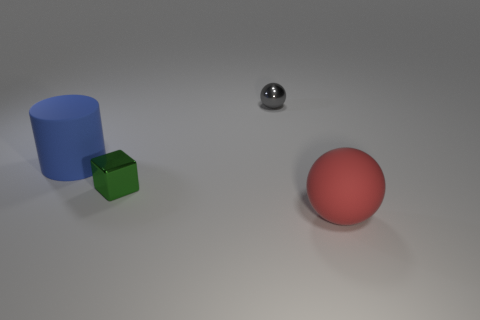Add 2 big brown shiny cylinders. How many objects exist? 6 Subtract all cubes. How many objects are left? 3 Add 4 rubber things. How many rubber things are left? 6 Add 2 big blue cylinders. How many big blue cylinders exist? 3 Subtract 0 brown balls. How many objects are left? 4 Subtract all small cyan shiny cylinders. Subtract all tiny cubes. How many objects are left? 3 